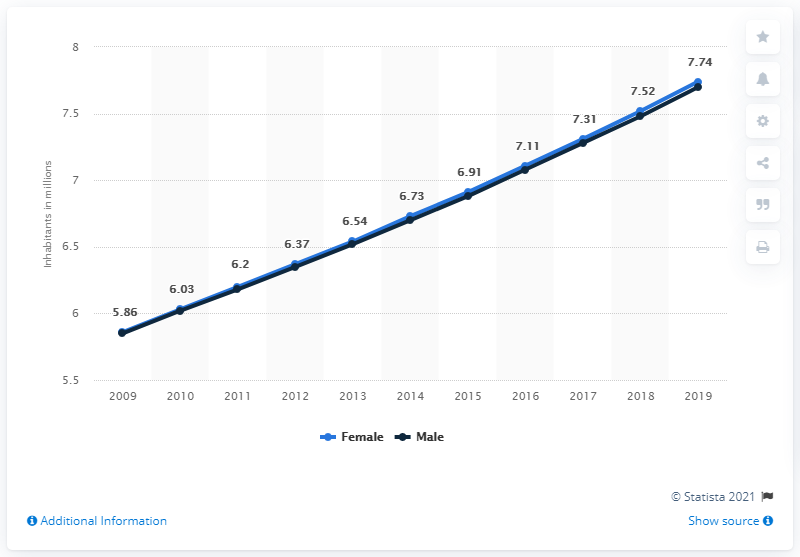Identify some key points in this picture. In 2019, the male population of Somalia was approximately 7.74 million. 